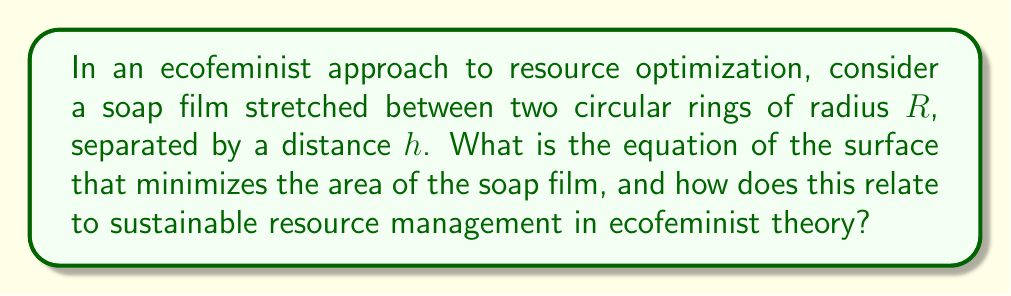Can you answer this question? To solve this problem, we'll follow these steps:

1) The surface of revolution that minimizes the area is called a catenoid. Its equation in cylindrical coordinates $(r, \theta, z)$ is:

   $$r = a \cosh(\frac{z}{a})$$

   where $a$ is a constant to be determined.

2) The boundary conditions are:
   At $z = 0$ and $z = h$, $r = R$

3) Applying these conditions:
   $$R = a \cosh(0) = a$$
   $$R = a \cosh(\frac{h}{a})$$

4) From the second equation:
   $$\cosh(\frac{h}{a}) = \frac{R}{a}$$

5) This equation can be solved numerically for $a$ given $R$ and $h$.

6) The minimal surface area is then given by:
   $$A = 2\pi a^2 [\sinh(\frac{h}{a}) - \frac{h}{a}]$$

7) In ecofeminist theory, this minimal surface represents the most efficient use of resources. The catenoid shape symbolizes the interconnectedness of all parts of the ecosystem, reflecting the holistic approach of ecofeminism.

8) The parameter $a$ represents the balance point between the separation ($h$) and the radius ($R$) of the rings, analogous to finding equilibrium between different aspects of sustainable resource management.

9) The minimal surface area ($A$) represents the optimal resource allocation, demonstrating how ecofeminist principles can lead to efficient and sustainable practices.
Answer: $r = a \cosh(\frac{z}{a})$, where $a$ satisfies $\cosh(\frac{h}{a}) = \frac{R}{a}$ 